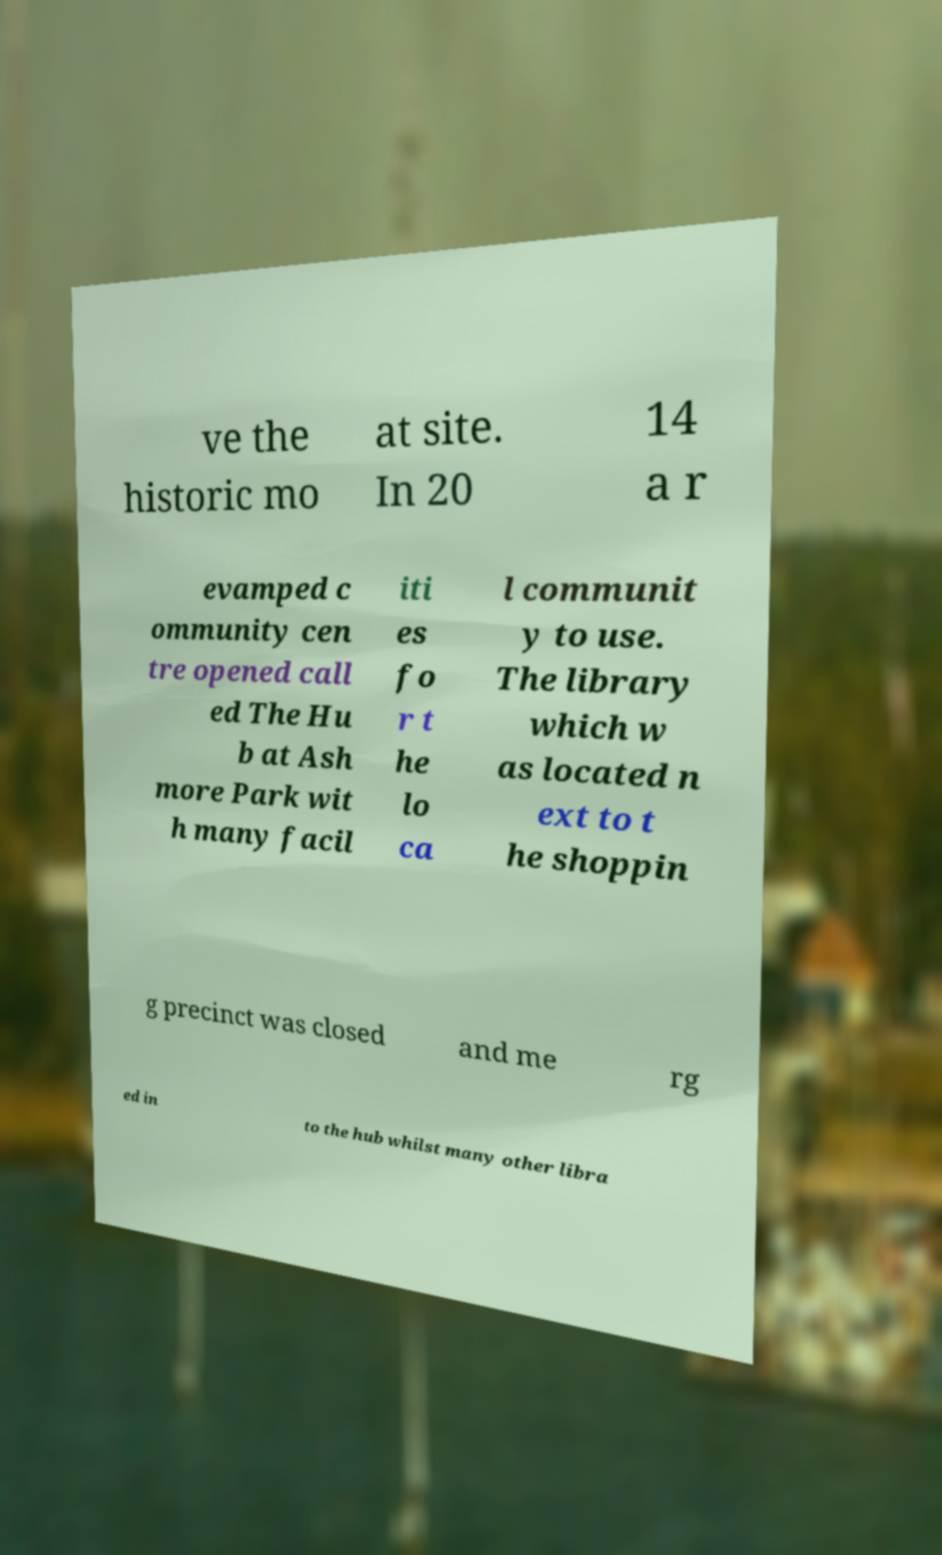Please identify and transcribe the text found in this image. ve the historic mo at site. In 20 14 a r evamped c ommunity cen tre opened call ed The Hu b at Ash more Park wit h many facil iti es fo r t he lo ca l communit y to use. The library which w as located n ext to t he shoppin g precinct was closed and me rg ed in to the hub whilst many other libra 